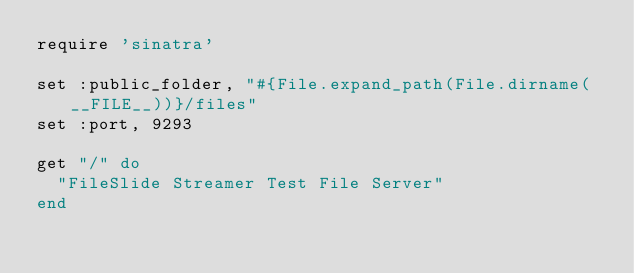<code> <loc_0><loc_0><loc_500><loc_500><_Ruby_>require 'sinatra'

set :public_folder, "#{File.expand_path(File.dirname(__FILE__))}/files"
set :port, 9293
 
get "/" do
  "FileSlide Streamer Test File Server"
end
</code> 